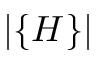Convert formula to latex. <formula><loc_0><loc_0><loc_500><loc_500>| \{ H \} |</formula> 